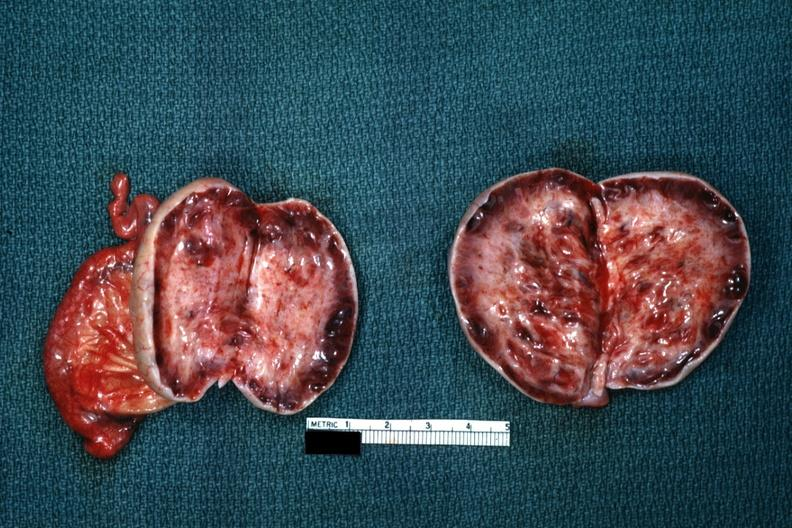where does this belong to?
Answer the question using a single word or phrase. Female reproductive system 